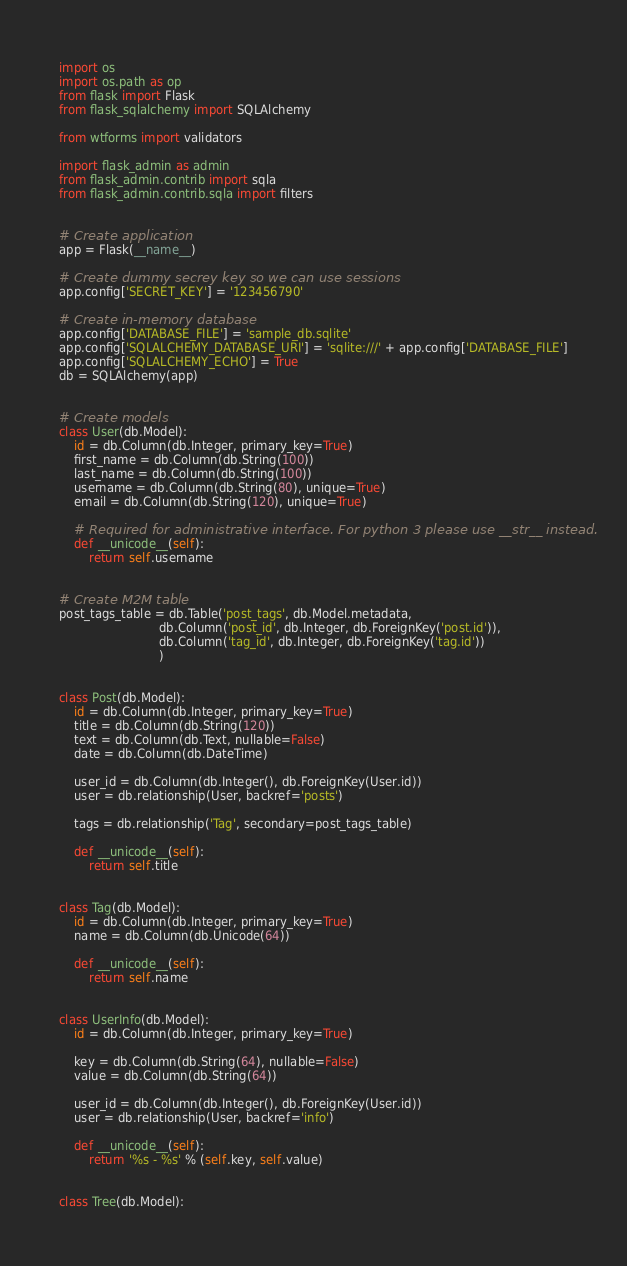Convert code to text. <code><loc_0><loc_0><loc_500><loc_500><_Python_>import os
import os.path as op
from flask import Flask
from flask_sqlalchemy import SQLAlchemy

from wtforms import validators

import flask_admin as admin
from flask_admin.contrib import sqla
from flask_admin.contrib.sqla import filters


# Create application
app = Flask(__name__)

# Create dummy secrey key so we can use sessions
app.config['SECRET_KEY'] = '123456790'

# Create in-memory database
app.config['DATABASE_FILE'] = 'sample_db.sqlite'
app.config['SQLALCHEMY_DATABASE_URI'] = 'sqlite:///' + app.config['DATABASE_FILE']
app.config['SQLALCHEMY_ECHO'] = True
db = SQLAlchemy(app)


# Create models
class User(db.Model):
    id = db.Column(db.Integer, primary_key=True)
    first_name = db.Column(db.String(100))
    last_name = db.Column(db.String(100))
    username = db.Column(db.String(80), unique=True)
    email = db.Column(db.String(120), unique=True)

    # Required for administrative interface. For python 3 please use __str__ instead.
    def __unicode__(self):
        return self.username


# Create M2M table
post_tags_table = db.Table('post_tags', db.Model.metadata,
                           db.Column('post_id', db.Integer, db.ForeignKey('post.id')),
                           db.Column('tag_id', db.Integer, db.ForeignKey('tag.id'))
                           )


class Post(db.Model):
    id = db.Column(db.Integer, primary_key=True)
    title = db.Column(db.String(120))
    text = db.Column(db.Text, nullable=False)
    date = db.Column(db.DateTime)

    user_id = db.Column(db.Integer(), db.ForeignKey(User.id))
    user = db.relationship(User, backref='posts')

    tags = db.relationship('Tag', secondary=post_tags_table)

    def __unicode__(self):
        return self.title


class Tag(db.Model):
    id = db.Column(db.Integer, primary_key=True)
    name = db.Column(db.Unicode(64))

    def __unicode__(self):
        return self.name


class UserInfo(db.Model):
    id = db.Column(db.Integer, primary_key=True)

    key = db.Column(db.String(64), nullable=False)
    value = db.Column(db.String(64))

    user_id = db.Column(db.Integer(), db.ForeignKey(User.id))
    user = db.relationship(User, backref='info')

    def __unicode__(self):
        return '%s - %s' % (self.key, self.value)


class Tree(db.Model):</code> 